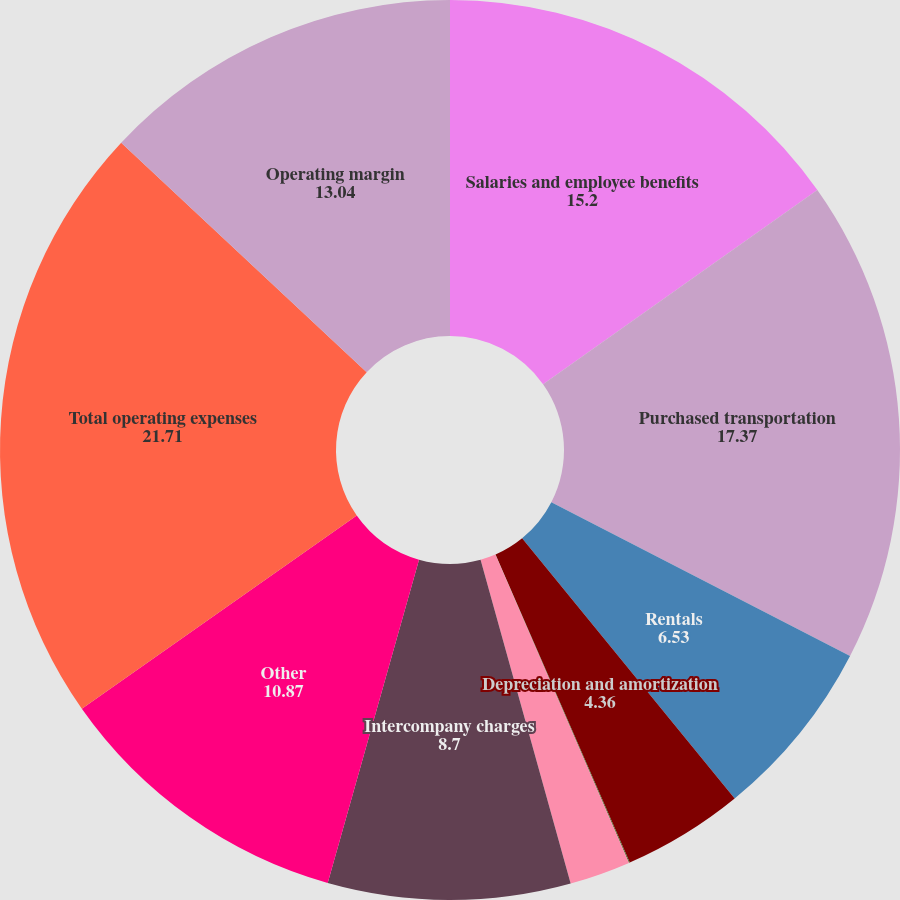<chart> <loc_0><loc_0><loc_500><loc_500><pie_chart><fcel>Salaries and employee benefits<fcel>Purchased transportation<fcel>Rentals<fcel>Depreciation and amortization<fcel>Fuel<fcel>Maintenance and repairs<fcel>Intercompany charges<fcel>Other<fcel>Total operating expenses<fcel>Operating margin<nl><fcel>15.2%<fcel>17.37%<fcel>6.53%<fcel>4.36%<fcel>0.03%<fcel>2.19%<fcel>8.7%<fcel>10.87%<fcel>21.71%<fcel>13.04%<nl></chart> 